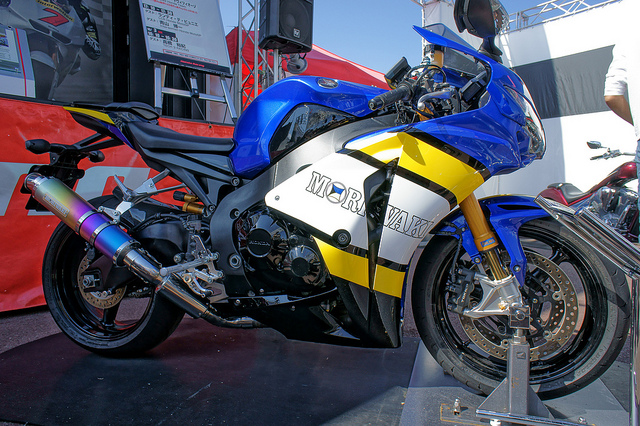Please identify all text content in this image. MORK VAK 